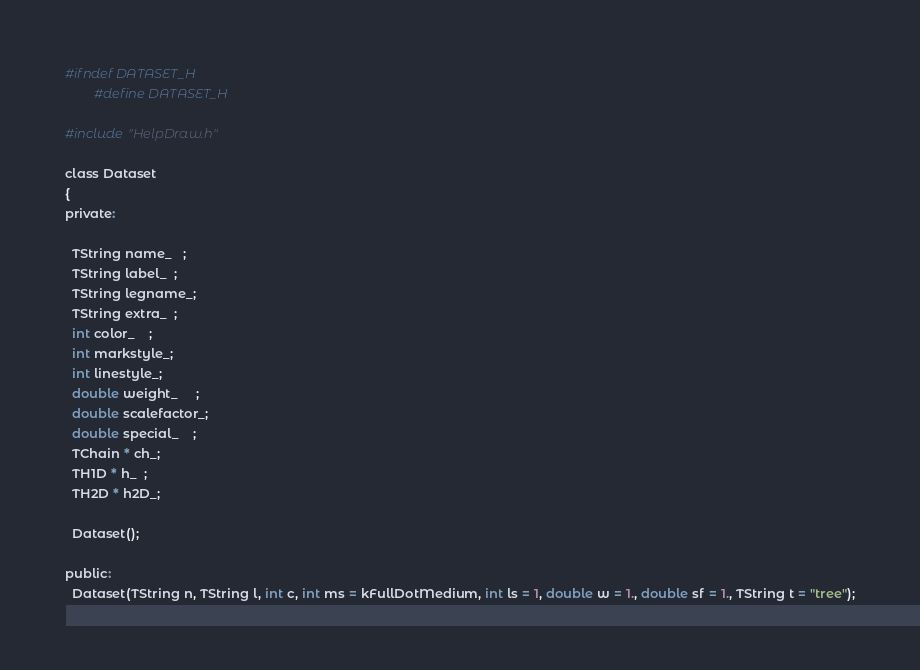<code> <loc_0><loc_0><loc_500><loc_500><_C_>
#ifndef DATASET_H
        #define DATASET_H

#include "HelpDraw.h"

class Dataset
{
private:

  TString name_   ;
  TString label_  ;
  TString legname_;
  TString extra_  ;
  int color_    ;
  int markstyle_;
  int linestyle_;
  double weight_     ;
  double scalefactor_;
  double special_    ;
  TChain * ch_;
  TH1D * h_  ;
  TH2D * h2D_;

  Dataset();

public:
  Dataset(TString n, TString l, int c, int ms = kFullDotMedium, int ls = 1, double w = 1., double sf = 1., TString t = "tree");</code> 